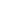<formula> <loc_0><loc_0><loc_500><loc_500>\begin{array} { r l l } \end{array}</formula> 